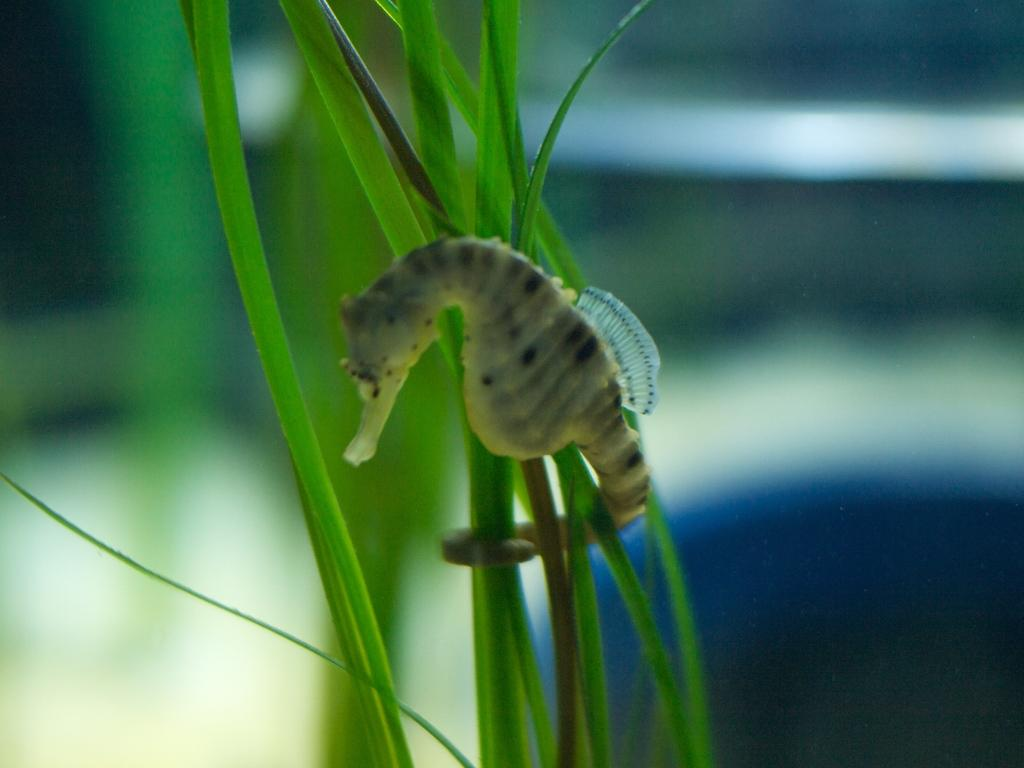What animal is featured in the image? There is a seahorse in the image. Where is the seahorse located? The seahorse is on the grass. Can you describe the background of the image? The background of the image is blurred. What degree of difficulty does the seahorse have in whistling in the image? Seahorses do not have the ability to whistle, so this question is not applicable to the image. 